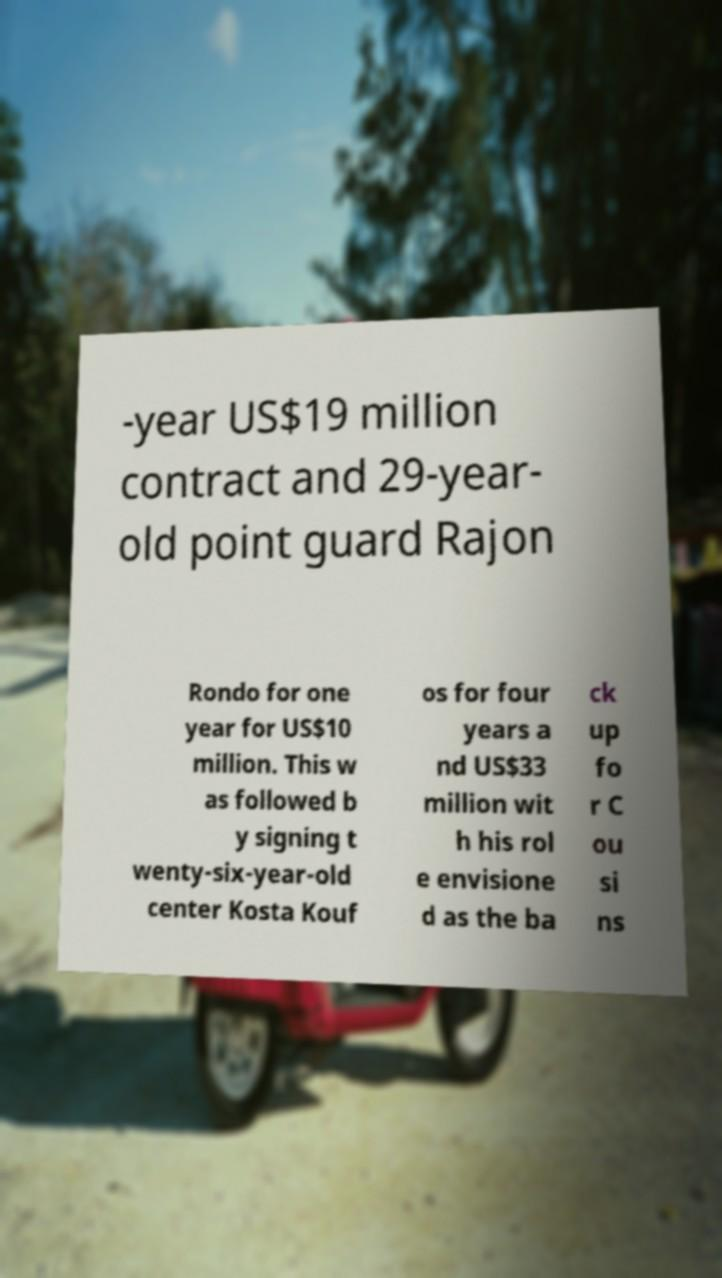There's text embedded in this image that I need extracted. Can you transcribe it verbatim? -year US$19 million contract and 29-year- old point guard Rajon Rondo for one year for US$10 million. This w as followed b y signing t wenty-six-year-old center Kosta Kouf os for four years a nd US$33 million wit h his rol e envisione d as the ba ck up fo r C ou si ns 